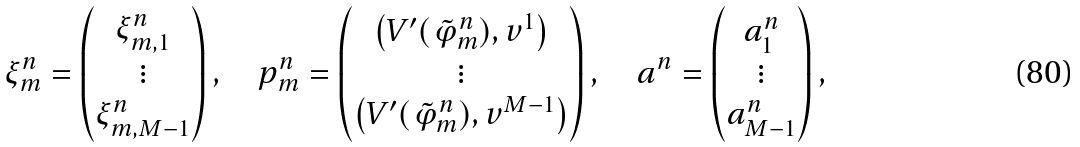<formula> <loc_0><loc_0><loc_500><loc_500>\xi ^ { n } _ { m } = \begin{pmatrix} \xi ^ { n } _ { m , 1 } \\ \vdots \\ \xi ^ { n } _ { m , M - 1 } \end{pmatrix} , \quad p ^ { n } _ { m } = \begin{pmatrix} \left ( V ^ { \prime } ( \tilde { \varphi } _ { m } ^ { n } ) , v ^ { 1 } \right ) \\ \vdots \\ \left ( V ^ { \prime } ( \tilde { \varphi } _ { m } ^ { n } ) , v ^ { M - 1 } \right ) \end{pmatrix} , \quad a ^ { n } = \begin{pmatrix} a ^ { n } _ { 1 } \\ \vdots \\ a ^ { n } _ { M - 1 } \end{pmatrix} ,</formula> 